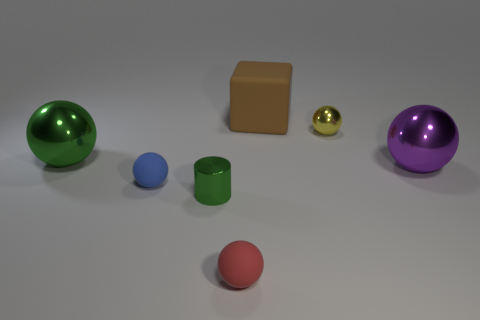Does the shiny ball to the left of the big matte thing have the same size as the matte sphere behind the small red object?
Your answer should be compact. No. Is there any other thing that is the same shape as the small green metal thing?
Your answer should be compact. No. Are any green blocks visible?
Ensure brevity in your answer.  No. Is the big thing that is to the right of the brown block made of the same material as the large thing that is behind the yellow metal ball?
Provide a short and direct response. No. What is the size of the purple sphere that is to the right of the object in front of the tiny shiny thing to the left of the big brown object?
Your response must be concise. Large. What number of blue cubes have the same material as the blue object?
Make the answer very short. 0. Are there fewer blue balls than large metallic cylinders?
Make the answer very short. No. What size is the purple thing that is the same shape as the yellow metallic thing?
Offer a very short reply. Large. Are the large thing that is left of the tiny blue object and the small red ball made of the same material?
Your answer should be compact. No. Do the tiny blue object and the big purple shiny object have the same shape?
Give a very brief answer. Yes. 